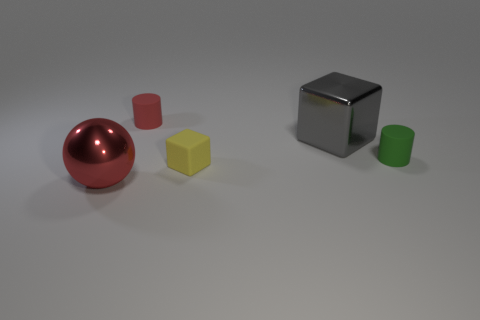There is a tiny object that is behind the gray metallic object; are there any matte things that are to the left of it?
Ensure brevity in your answer.  No. There is a small yellow thing; what shape is it?
Your answer should be very brief. Cube. There is a thing that is the same color as the sphere; what size is it?
Give a very brief answer. Small. There is a matte cylinder in front of the rubber cylinder behind the gray block; what is its size?
Your answer should be very brief. Small. There is a rubber cylinder on the left side of the small yellow block; how big is it?
Provide a short and direct response. Small. Are there fewer tiny red matte things that are in front of the large red thing than small red rubber cylinders in front of the large gray cube?
Keep it short and to the point. No. What is the color of the large sphere?
Your response must be concise. Red. Are there any cylinders that have the same color as the large ball?
Make the answer very short. Yes. There is a red object behind the large thing that is in front of the small cylinder to the right of the red rubber object; what is its shape?
Provide a succinct answer. Cylinder. What material is the large thing that is right of the metallic ball?
Your answer should be compact. Metal. 